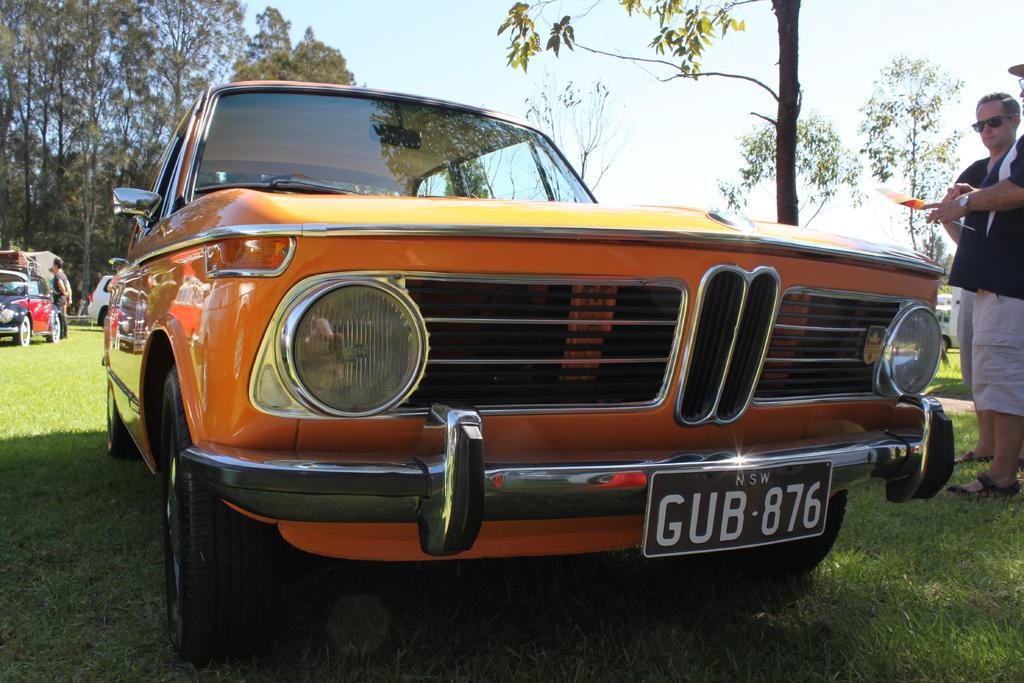Can you describe this image briefly? This picture shows few cars parked and few people standing and we see trees and grass on the ground and we see a blue cloudy sky and a man wore sunglasses on his face and we see a car in yellow color and another car in red color. 